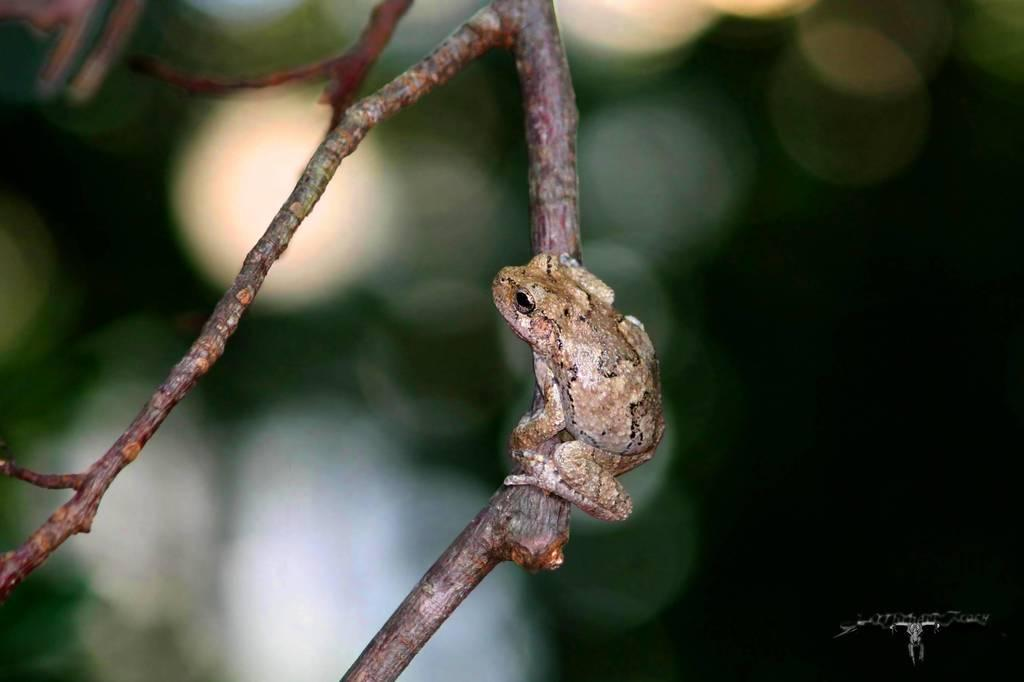What animal is present in the image? There is a frog in the image. Can you describe the background of the image? The background of the image is blurry. What type of error can be seen in the image? There is no error present in the image; it is a clear image of a frog with a blurry background. What type of play is depicted in the image? There is no play or any indication of a play in the image; it is a simple image of a frog with a blurry background. 